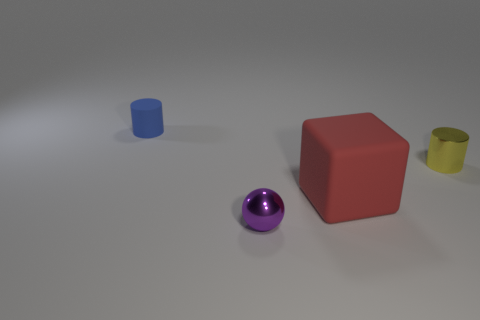Are there any small cylinders to the left of the ball?
Offer a terse response. Yes. There is a yellow cylinder that is made of the same material as the tiny purple sphere; what is its size?
Offer a terse response. Small. What number of tiny purple things have the same shape as the tiny blue rubber thing?
Offer a terse response. 0. Does the block have the same material as the tiny thing that is in front of the tiny yellow cylinder?
Ensure brevity in your answer.  No. Are there more small cylinders right of the blue cylinder than red shiny objects?
Offer a terse response. Yes. Are there any blue things made of the same material as the block?
Keep it short and to the point. Yes. Is the material of the tiny thing on the left side of the small metal sphere the same as the tiny yellow cylinder behind the big red block?
Offer a very short reply. No. Is the number of purple things that are right of the small yellow metallic thing the same as the number of red cubes that are behind the large rubber object?
Provide a short and direct response. Yes. The rubber cylinder that is the same size as the purple sphere is what color?
Give a very brief answer. Blue. How many things are either things that are in front of the rubber cylinder or small cylinders?
Ensure brevity in your answer.  4. 